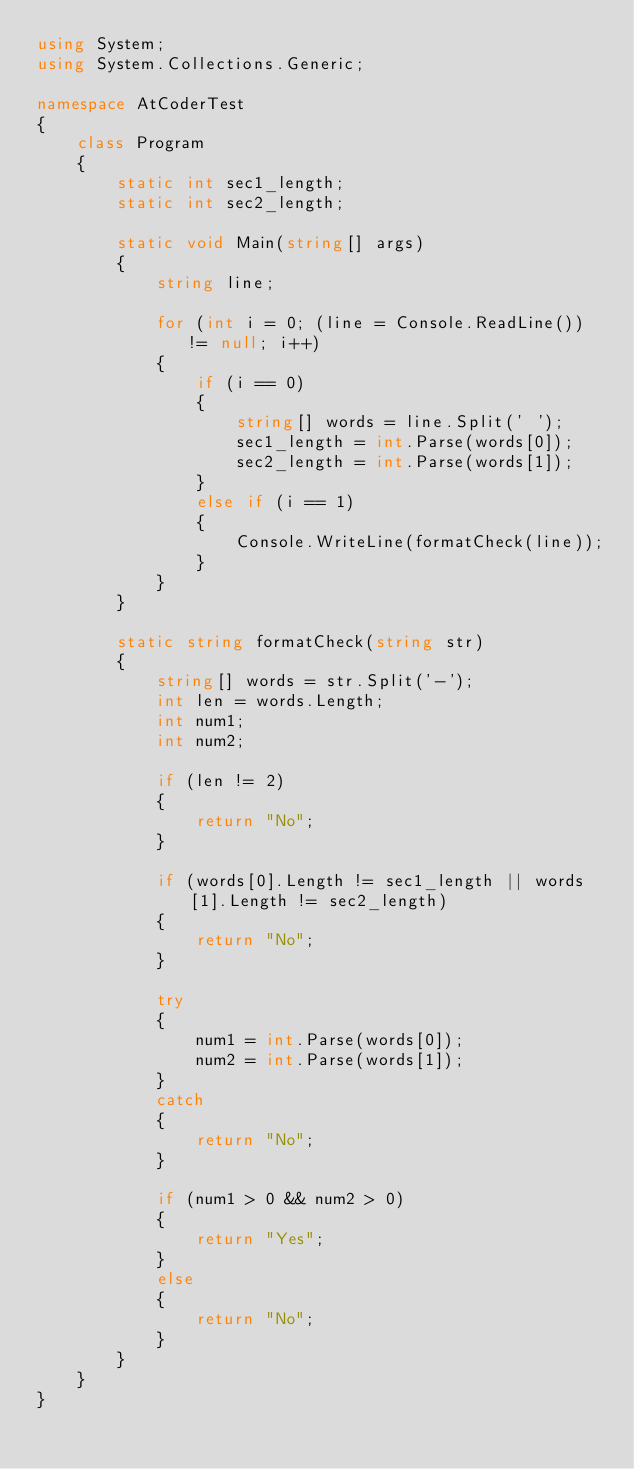<code> <loc_0><loc_0><loc_500><loc_500><_C#_>using System;
using System.Collections.Generic;

namespace AtCoderTest
{
    class Program
    {
        static int sec1_length;
        static int sec2_length;

        static void Main(string[] args)
        {
            string line;

            for (int i = 0; (line = Console.ReadLine()) != null; i++)
            {
                if (i == 0)
                {
                    string[] words = line.Split(' ');
                    sec1_length = int.Parse(words[0]);
                    sec2_length = int.Parse(words[1]);
                }
                else if (i == 1)
                {
                    Console.WriteLine(formatCheck(line));
                }
            }
        }

        static string formatCheck(string str)
        {
            string[] words = str.Split('-');
            int len = words.Length;
            int num1;
            int num2;
            
            if (len != 2)
            {
                return "No";
            }

            if (words[0].Length != sec1_length || words[1].Length != sec2_length)
            {
                return "No";
            }

            try
            {
                num1 = int.Parse(words[0]);
                num2 = int.Parse(words[1]);
            }
            catch
            {
                return "No";
            }

            if (num1 > 0 && num2 > 0)
            {
                return "Yes";
            }
            else
            {
                return "No";
            }
        }
    }
}
</code> 